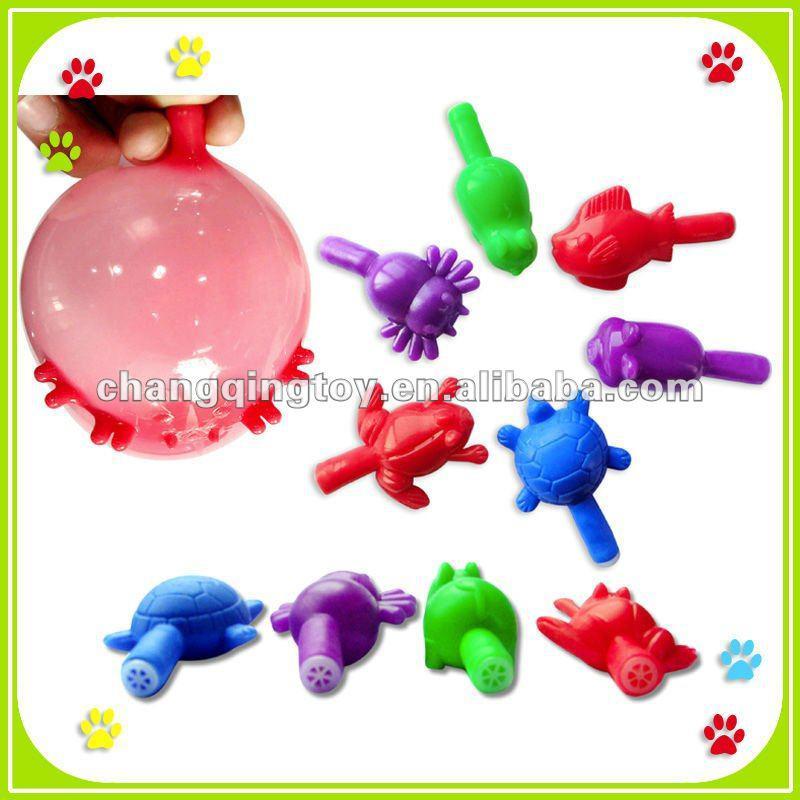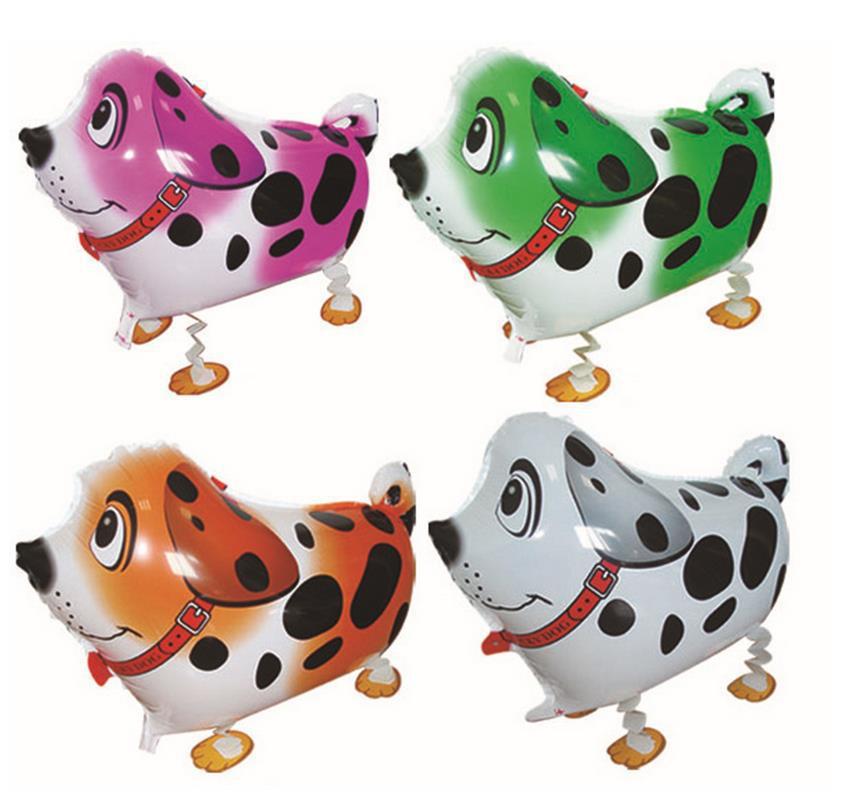The first image is the image on the left, the second image is the image on the right. For the images shown, is this caption "There are no more than three balloons" true? Answer yes or no. No. 